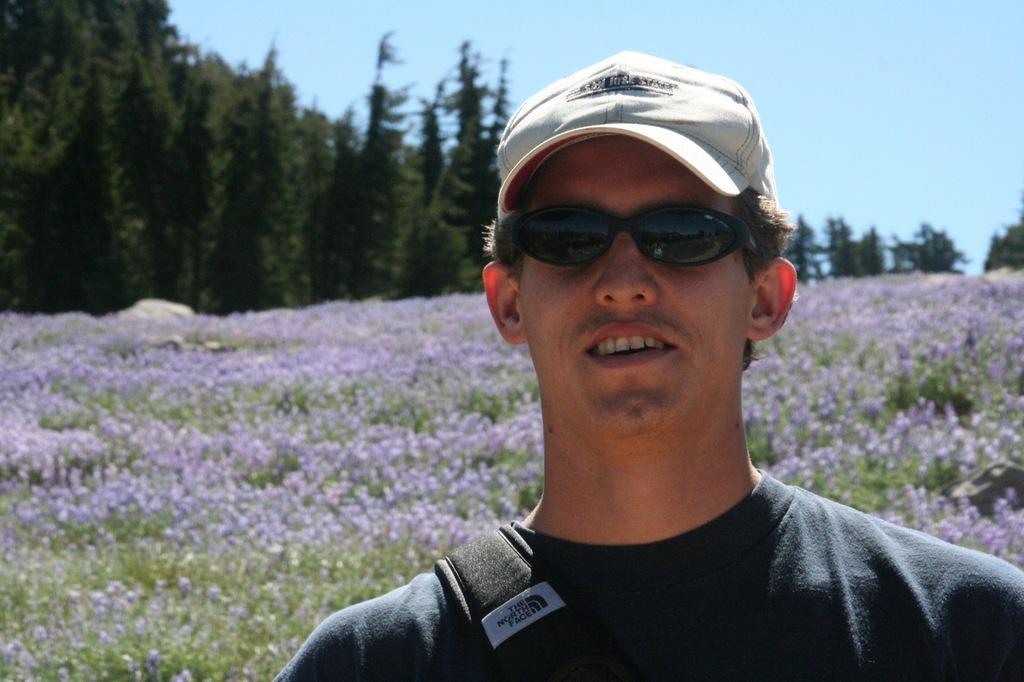Describe this image in one or two sentences. In this picture we can see a man wore a cap, goggles and smiling and at the back of him we can see flowers, trees and in the background we can see the sky. 